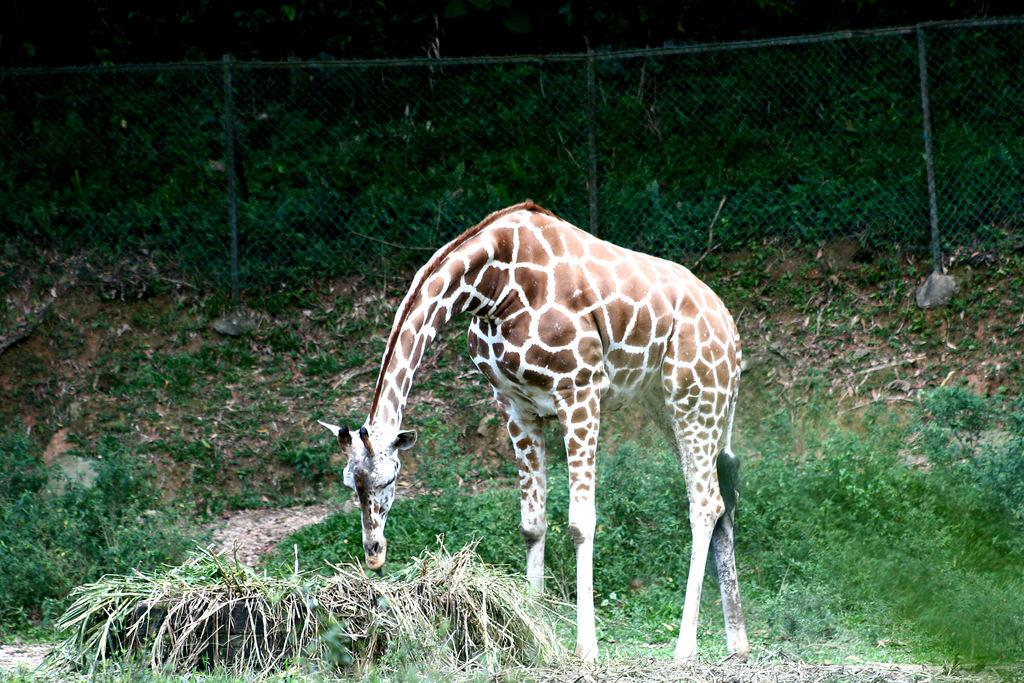What animal can be seen in the image? There is a giraffe in the image. What is the giraffe doing in the image? The giraffe is eating grass. What can be seen in the background of the image? There is fencing and trees in the background of the image. What type of bread is the giraffe holding in the image? There is no bread present in the image; the giraffe is eating grass. 